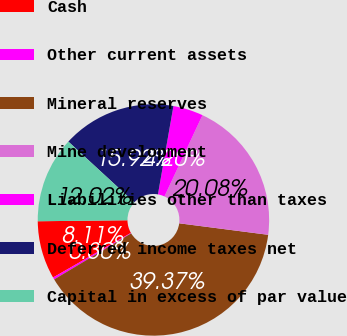Convert chart to OTSL. <chart><loc_0><loc_0><loc_500><loc_500><pie_chart><fcel>Cash<fcel>Other current assets<fcel>Mineral reserves<fcel>Mine development<fcel>Liabilities other than taxes<fcel>Deferred income taxes net<fcel>Capital in excess of par value<nl><fcel>8.11%<fcel>0.3%<fcel>39.37%<fcel>20.08%<fcel>4.2%<fcel>15.92%<fcel>12.02%<nl></chart> 